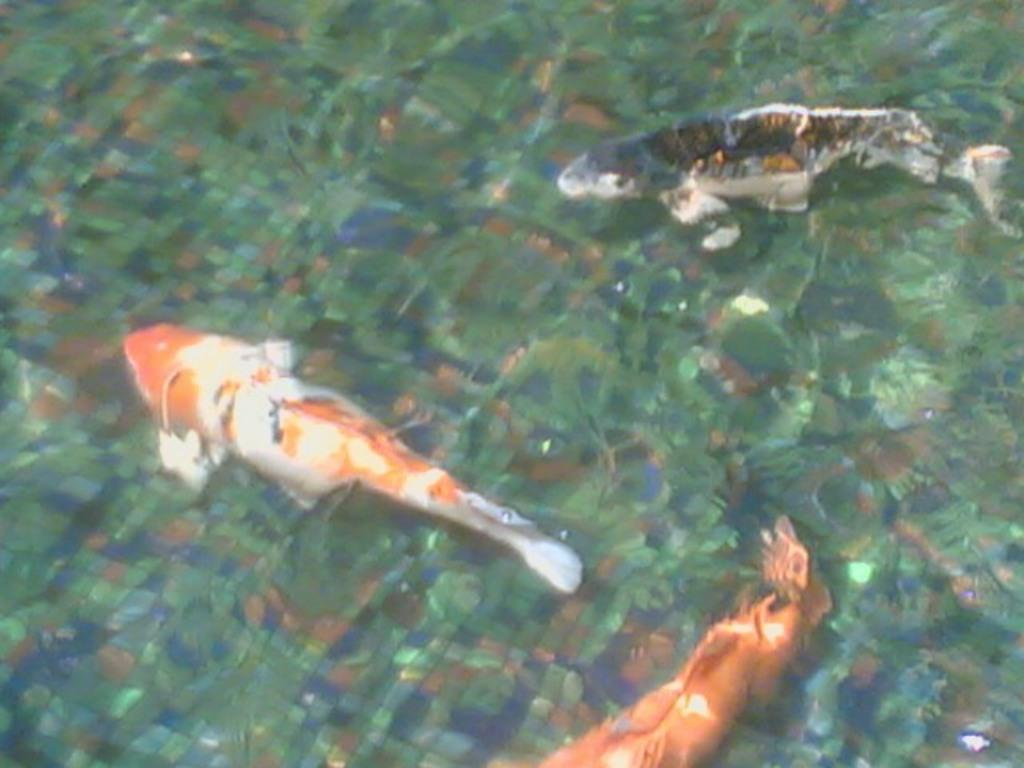How many fish are visible in the image? There are three fish in the image. Where are the fish located? The fish are in the water. What type of sail is attached to the doll in the image? There is no sail or doll present in the image; it features three fish in the water. 